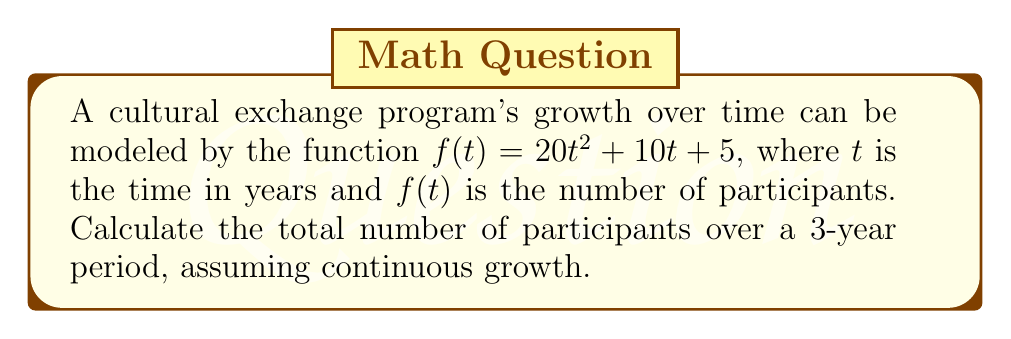Teach me how to tackle this problem. To find the total number of participants over a 3-year period, we need to calculate the area under the curve of $f(t)$ from $t=0$ to $t=3$. This can be done using definite integration.

1) The function is $f(t) = 20t^2 + 10t + 5$

2) We need to integrate this function from 0 to 3:

   $$\int_0^3 (20t^2 + 10t + 5) dt$$

3) Integrate each term:
   $$\left[\frac{20t^3}{3} + 5t^2 + 5t\right]_0^3$$

4) Evaluate at the upper and lower bounds:
   $$\left(\frac{20(3)^3}{3} + 5(3)^2 + 5(3)\right) - \left(\frac{20(0)^3}{3} + 5(0)^2 + 5(0)\right)$$

5) Simplify:
   $$\left(\frac{540}{3} + 45 + 15\right) - (0)$$
   $$= 180 + 45 + 15 = 240$$

Therefore, the total number of participants over the 3-year period is 240.
Answer: 240 participants 